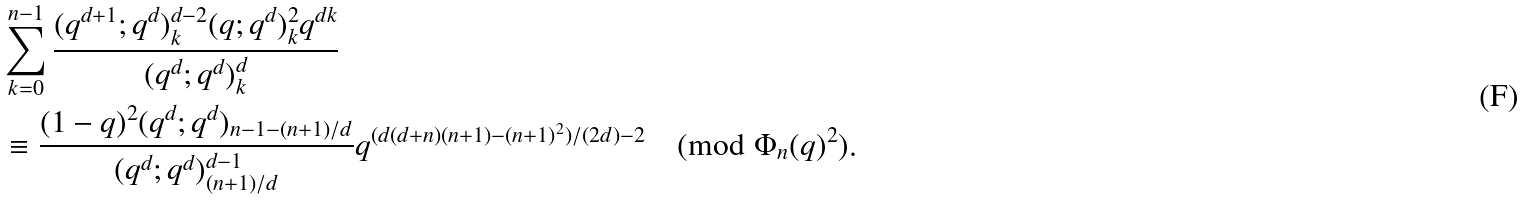<formula> <loc_0><loc_0><loc_500><loc_500>& \sum _ { k = 0 } ^ { n - 1 } \frac { ( q ^ { d + 1 } ; q ^ { d } ) _ { k } ^ { d - 2 } ( q ; q ^ { d } ) _ { k } ^ { 2 } q ^ { d k } } { ( q ^ { d } ; q ^ { d } ) _ { k } ^ { d } } \\ & \equiv \frac { ( 1 - q ) ^ { 2 } ( q ^ { d } ; q ^ { d } ) _ { n - 1 - ( n + 1 ) / d } } { ( q ^ { d } ; q ^ { d } ) _ { ( n + 1 ) / d } ^ { d - 1 } } q ^ { ( d ( d + n ) ( n + 1 ) - ( n + 1 ) ^ { 2 } ) / ( 2 d ) - 2 } \pmod { \Phi _ { n } ( q ) ^ { 2 } } .</formula> 